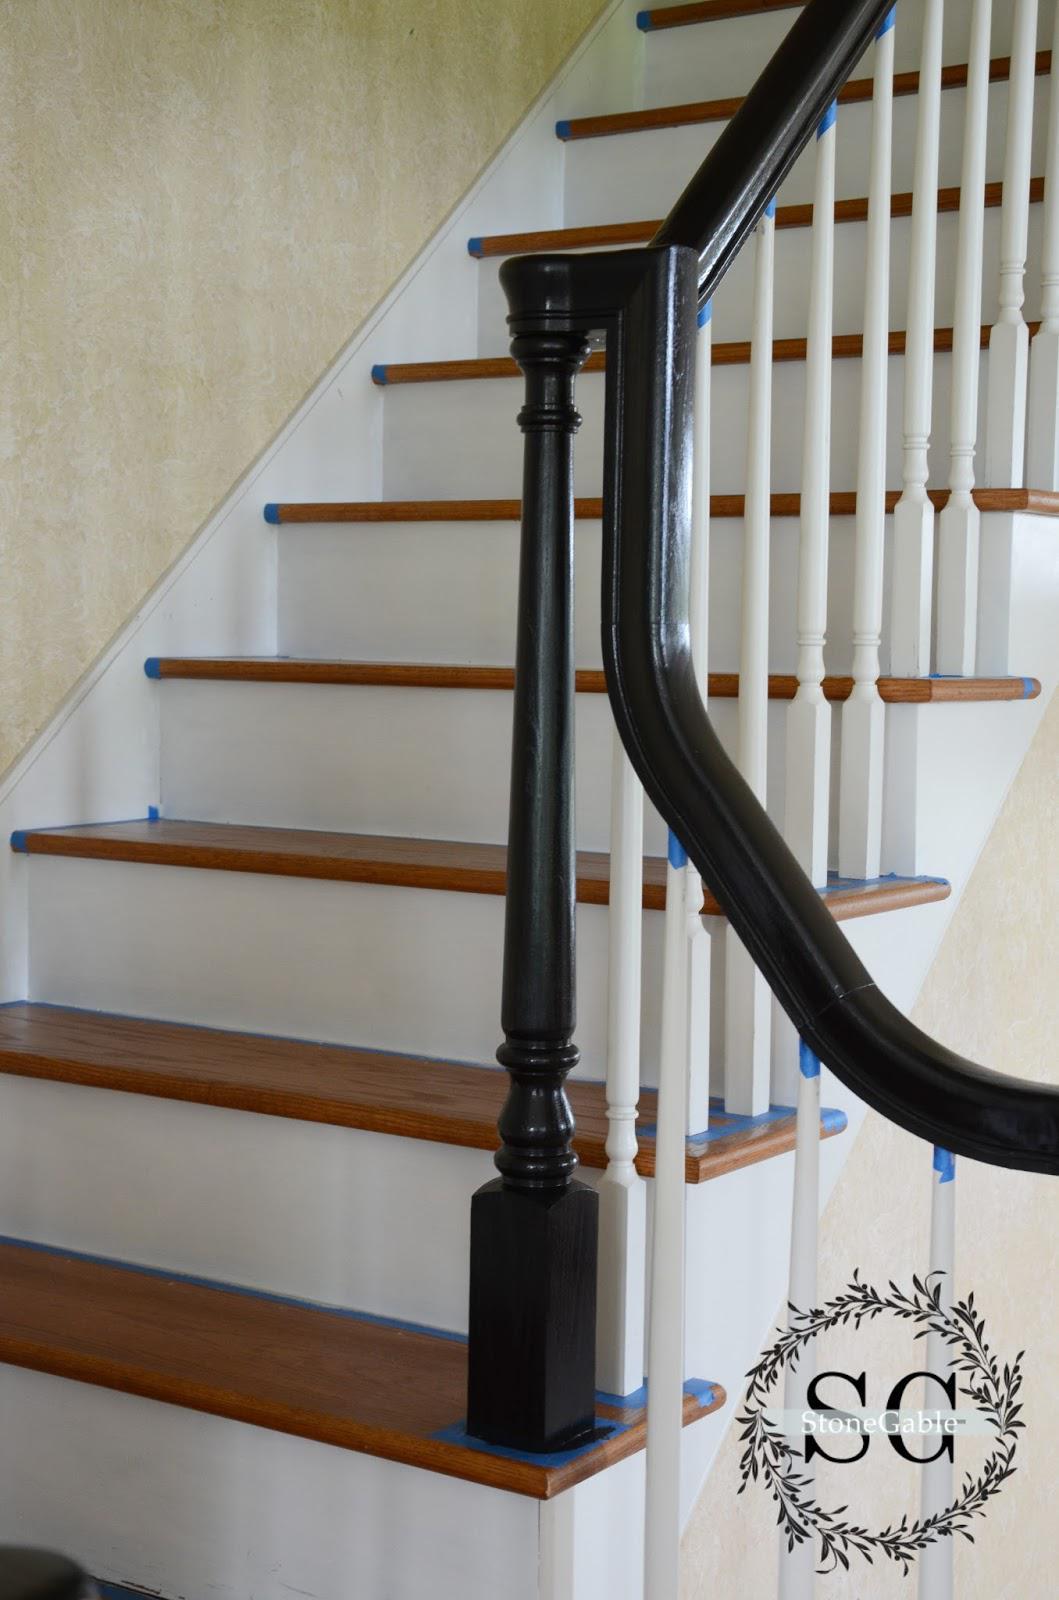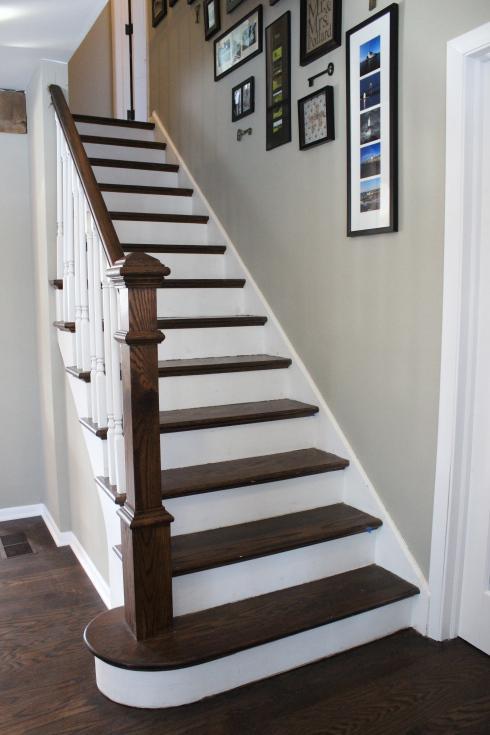The first image is the image on the left, the second image is the image on the right. Evaluate the accuracy of this statement regarding the images: "Some stairs are curved.". Is it true? Answer yes or no. No. The first image is the image on the left, the second image is the image on the right. For the images displayed, is the sentence "One image shows a curving staircase with black steps and handrails and white spindles that ascends to a second story." factually correct? Answer yes or no. No. 